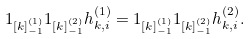Convert formula to latex. <formula><loc_0><loc_0><loc_500><loc_500>1 _ { [ k ] ^ { ( 1 ) } _ { - 1 } } 1 _ { [ k ] ^ { ( 2 ) } _ { - 1 } } h _ { k , i } ^ { ( 1 ) } = 1 _ { [ k ] ^ { ( 1 ) } _ { - 1 } } 1 _ { [ k ] ^ { ( 2 ) } _ { - 1 } } h _ { k , i } ^ { ( 2 ) } .</formula> 